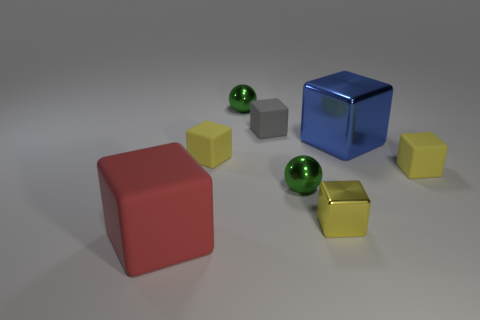Subtract all yellow cubes. How many were subtracted if there are1yellow cubes left? 2 Subtract all brown cylinders. How many yellow blocks are left? 3 Subtract all small yellow shiny blocks. How many blocks are left? 5 Subtract all blue cubes. How many cubes are left? 5 Subtract all gray blocks. Subtract all green balls. How many blocks are left? 5 Add 2 big green shiny cubes. How many objects exist? 10 Subtract all cubes. How many objects are left? 2 Add 1 yellow metal blocks. How many yellow metal blocks exist? 2 Subtract 1 green spheres. How many objects are left? 7 Subtract all tiny red metal cylinders. Subtract all tiny metallic things. How many objects are left? 5 